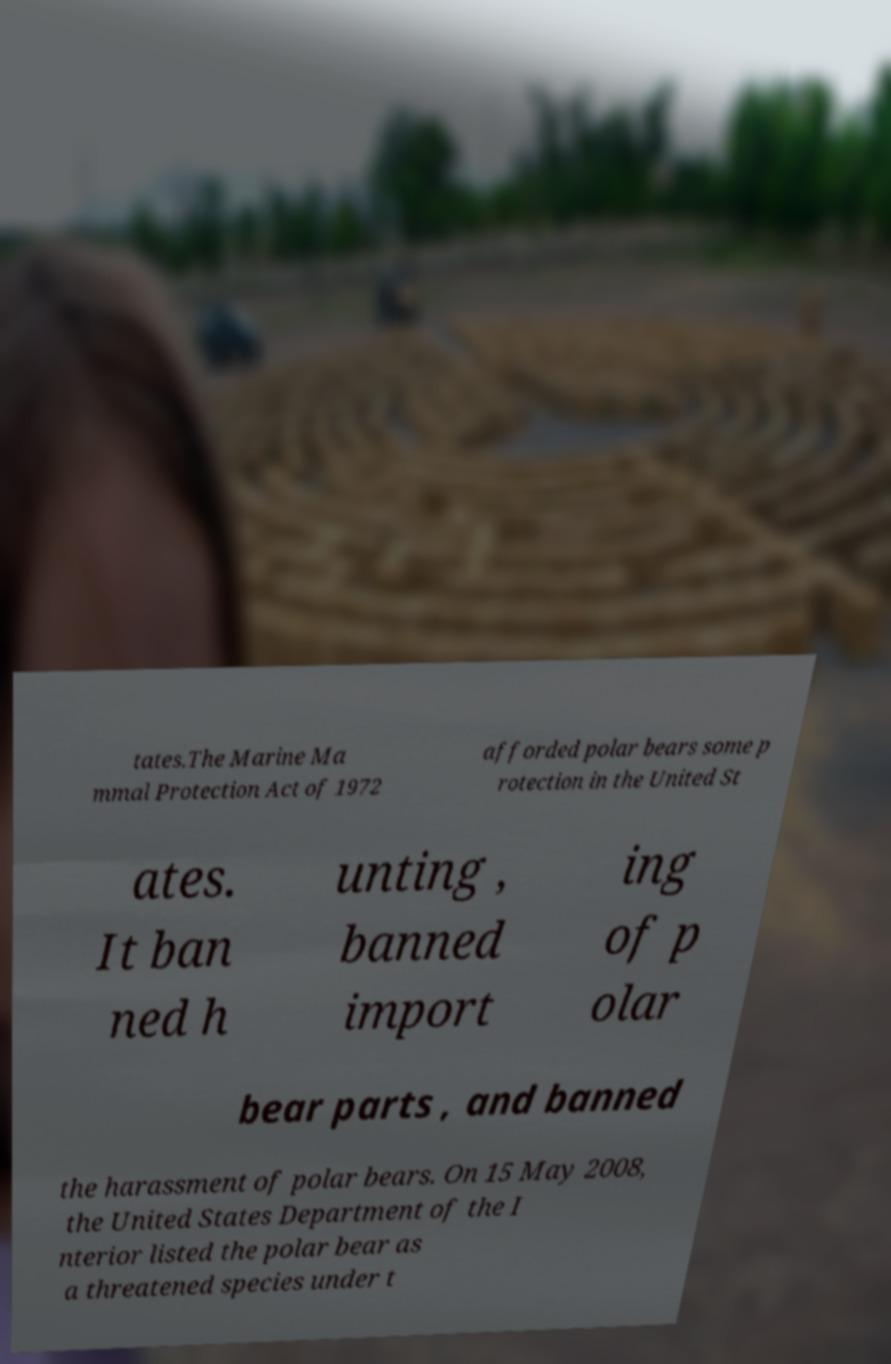Could you extract and type out the text from this image? tates.The Marine Ma mmal Protection Act of 1972 afforded polar bears some p rotection in the United St ates. It ban ned h unting , banned import ing of p olar bear parts , and banned the harassment of polar bears. On 15 May 2008, the United States Department of the I nterior listed the polar bear as a threatened species under t 